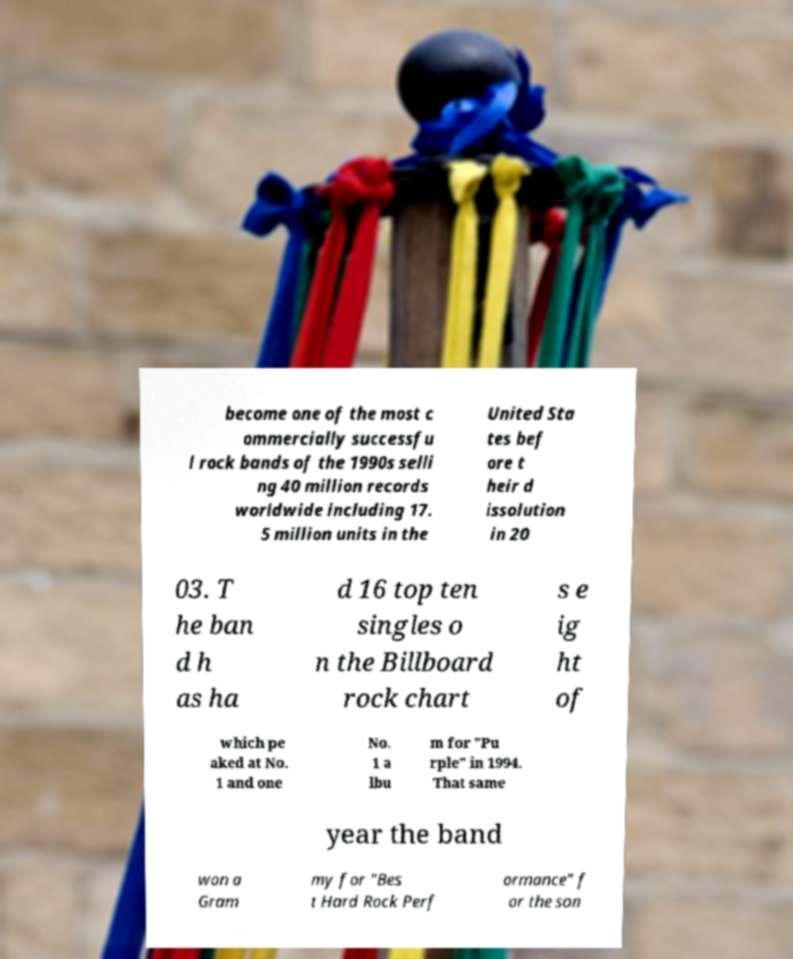Please identify and transcribe the text found in this image. become one of the most c ommercially successfu l rock bands of the 1990s selli ng 40 million records worldwide including 17. 5 million units in the United Sta tes bef ore t heir d issolution in 20 03. T he ban d h as ha d 16 top ten singles o n the Billboard rock chart s e ig ht of which pe aked at No. 1 and one No. 1 a lbu m for "Pu rple" in 1994. That same year the band won a Gram my for "Bes t Hard Rock Perf ormance" f or the son 